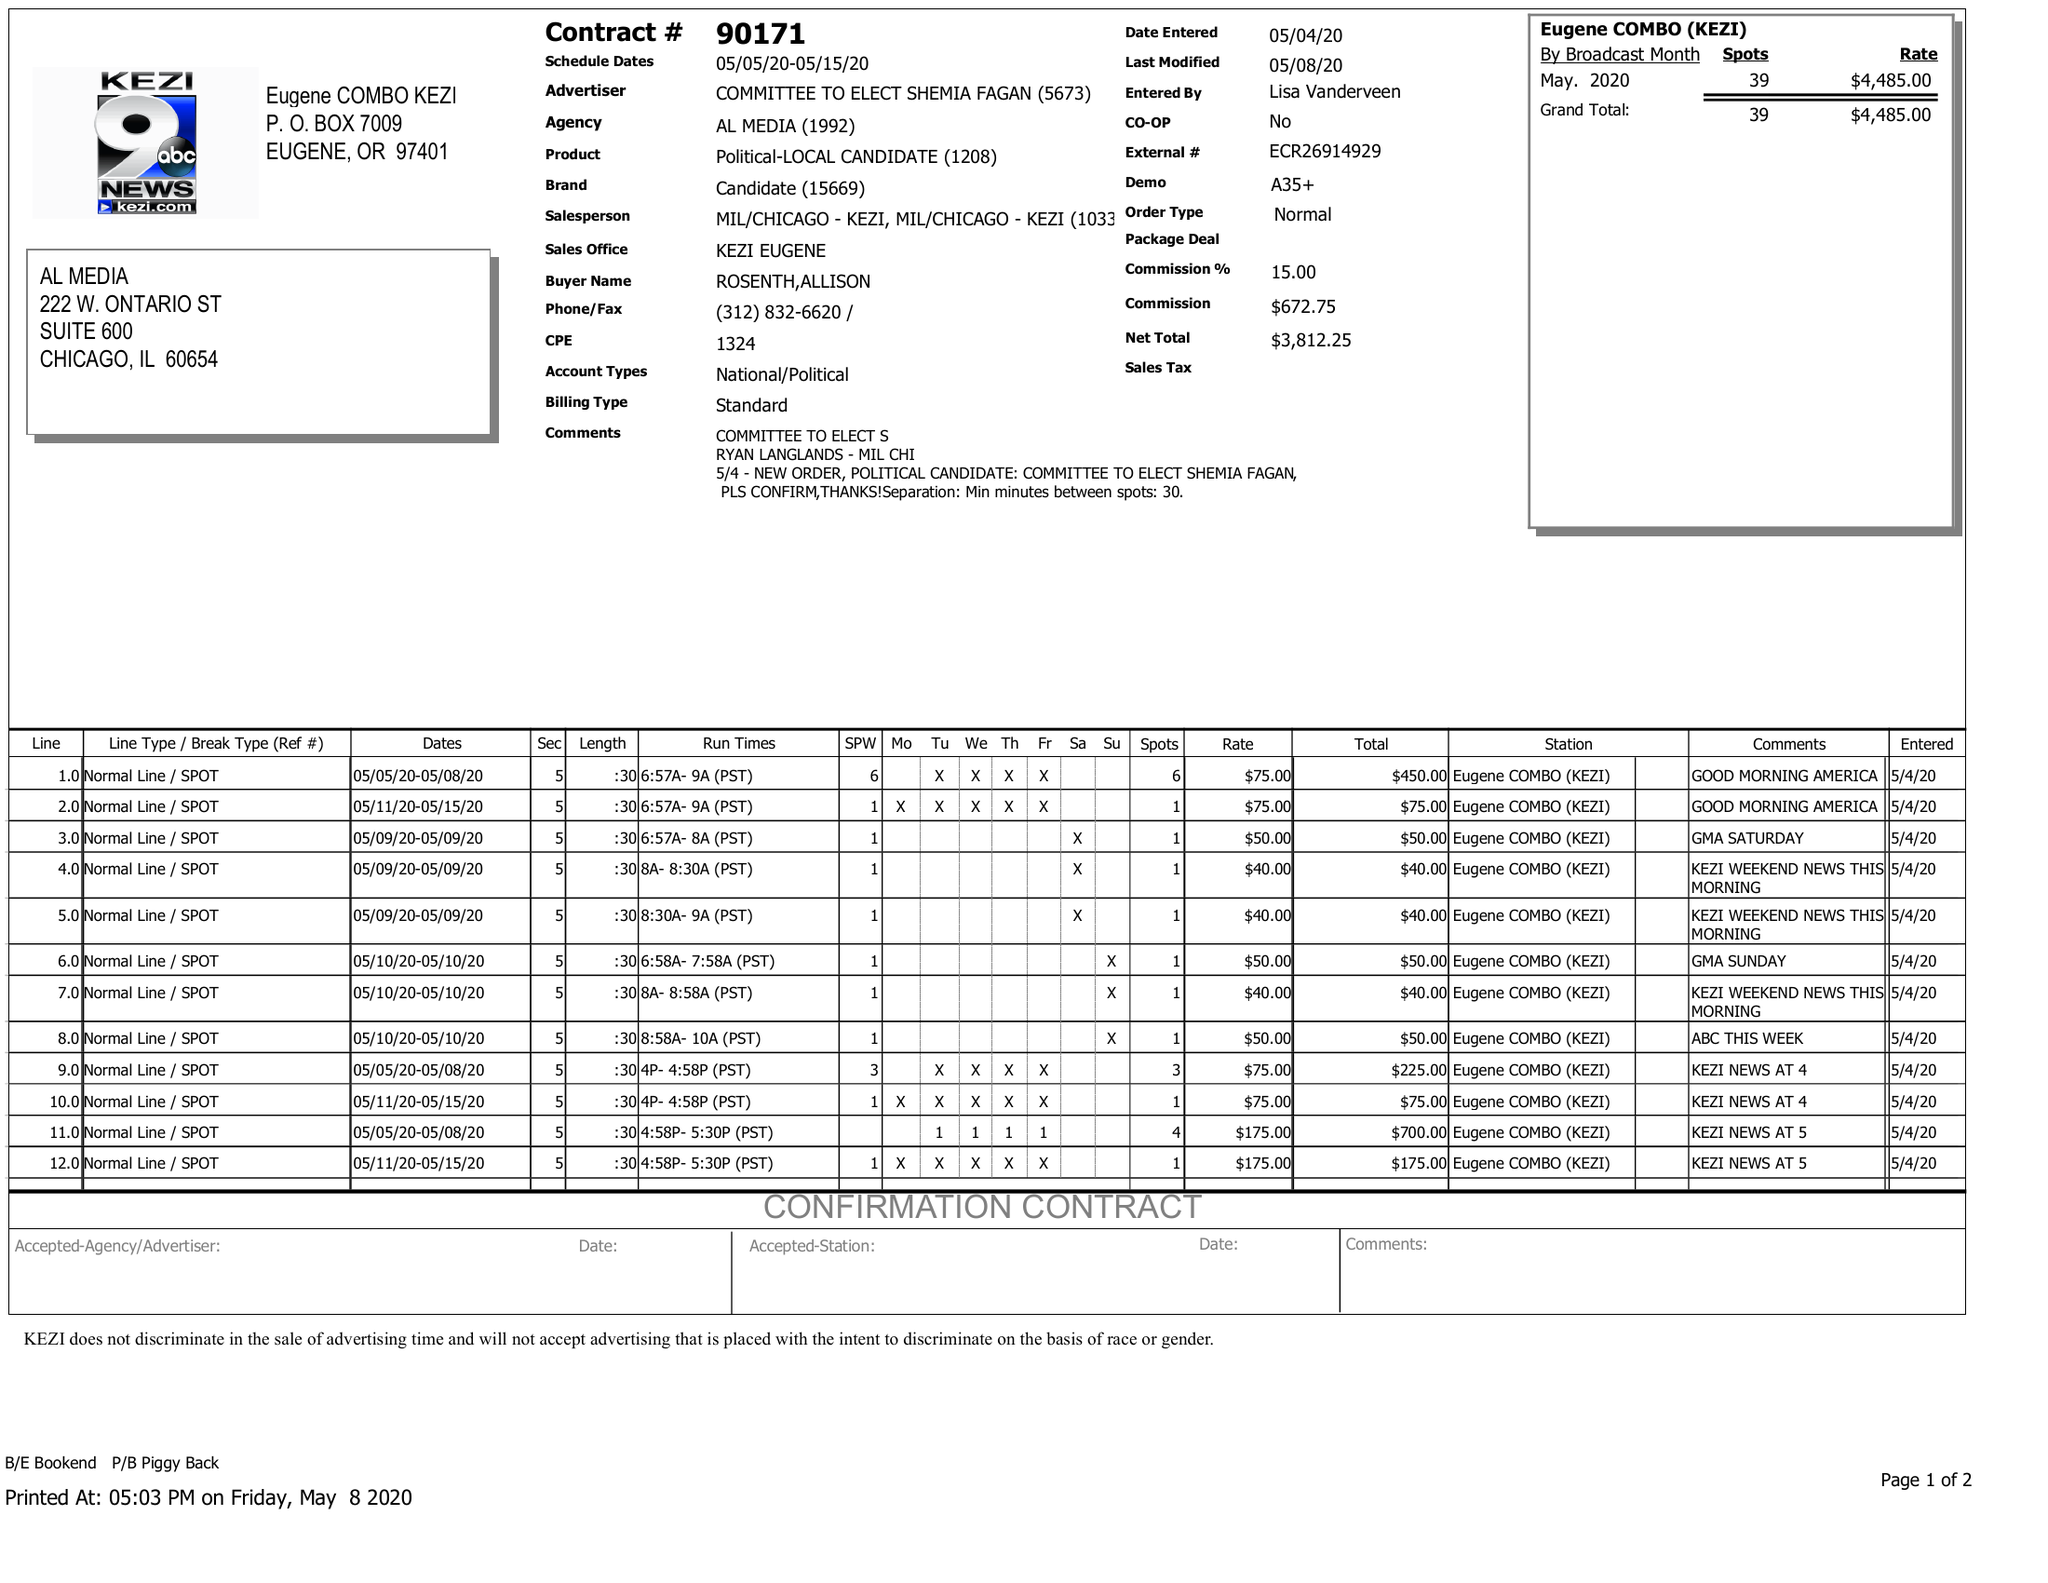What is the value for the advertiser?
Answer the question using a single word or phrase. COMMITTEE TO ELECT SHEMIA FAGAN 